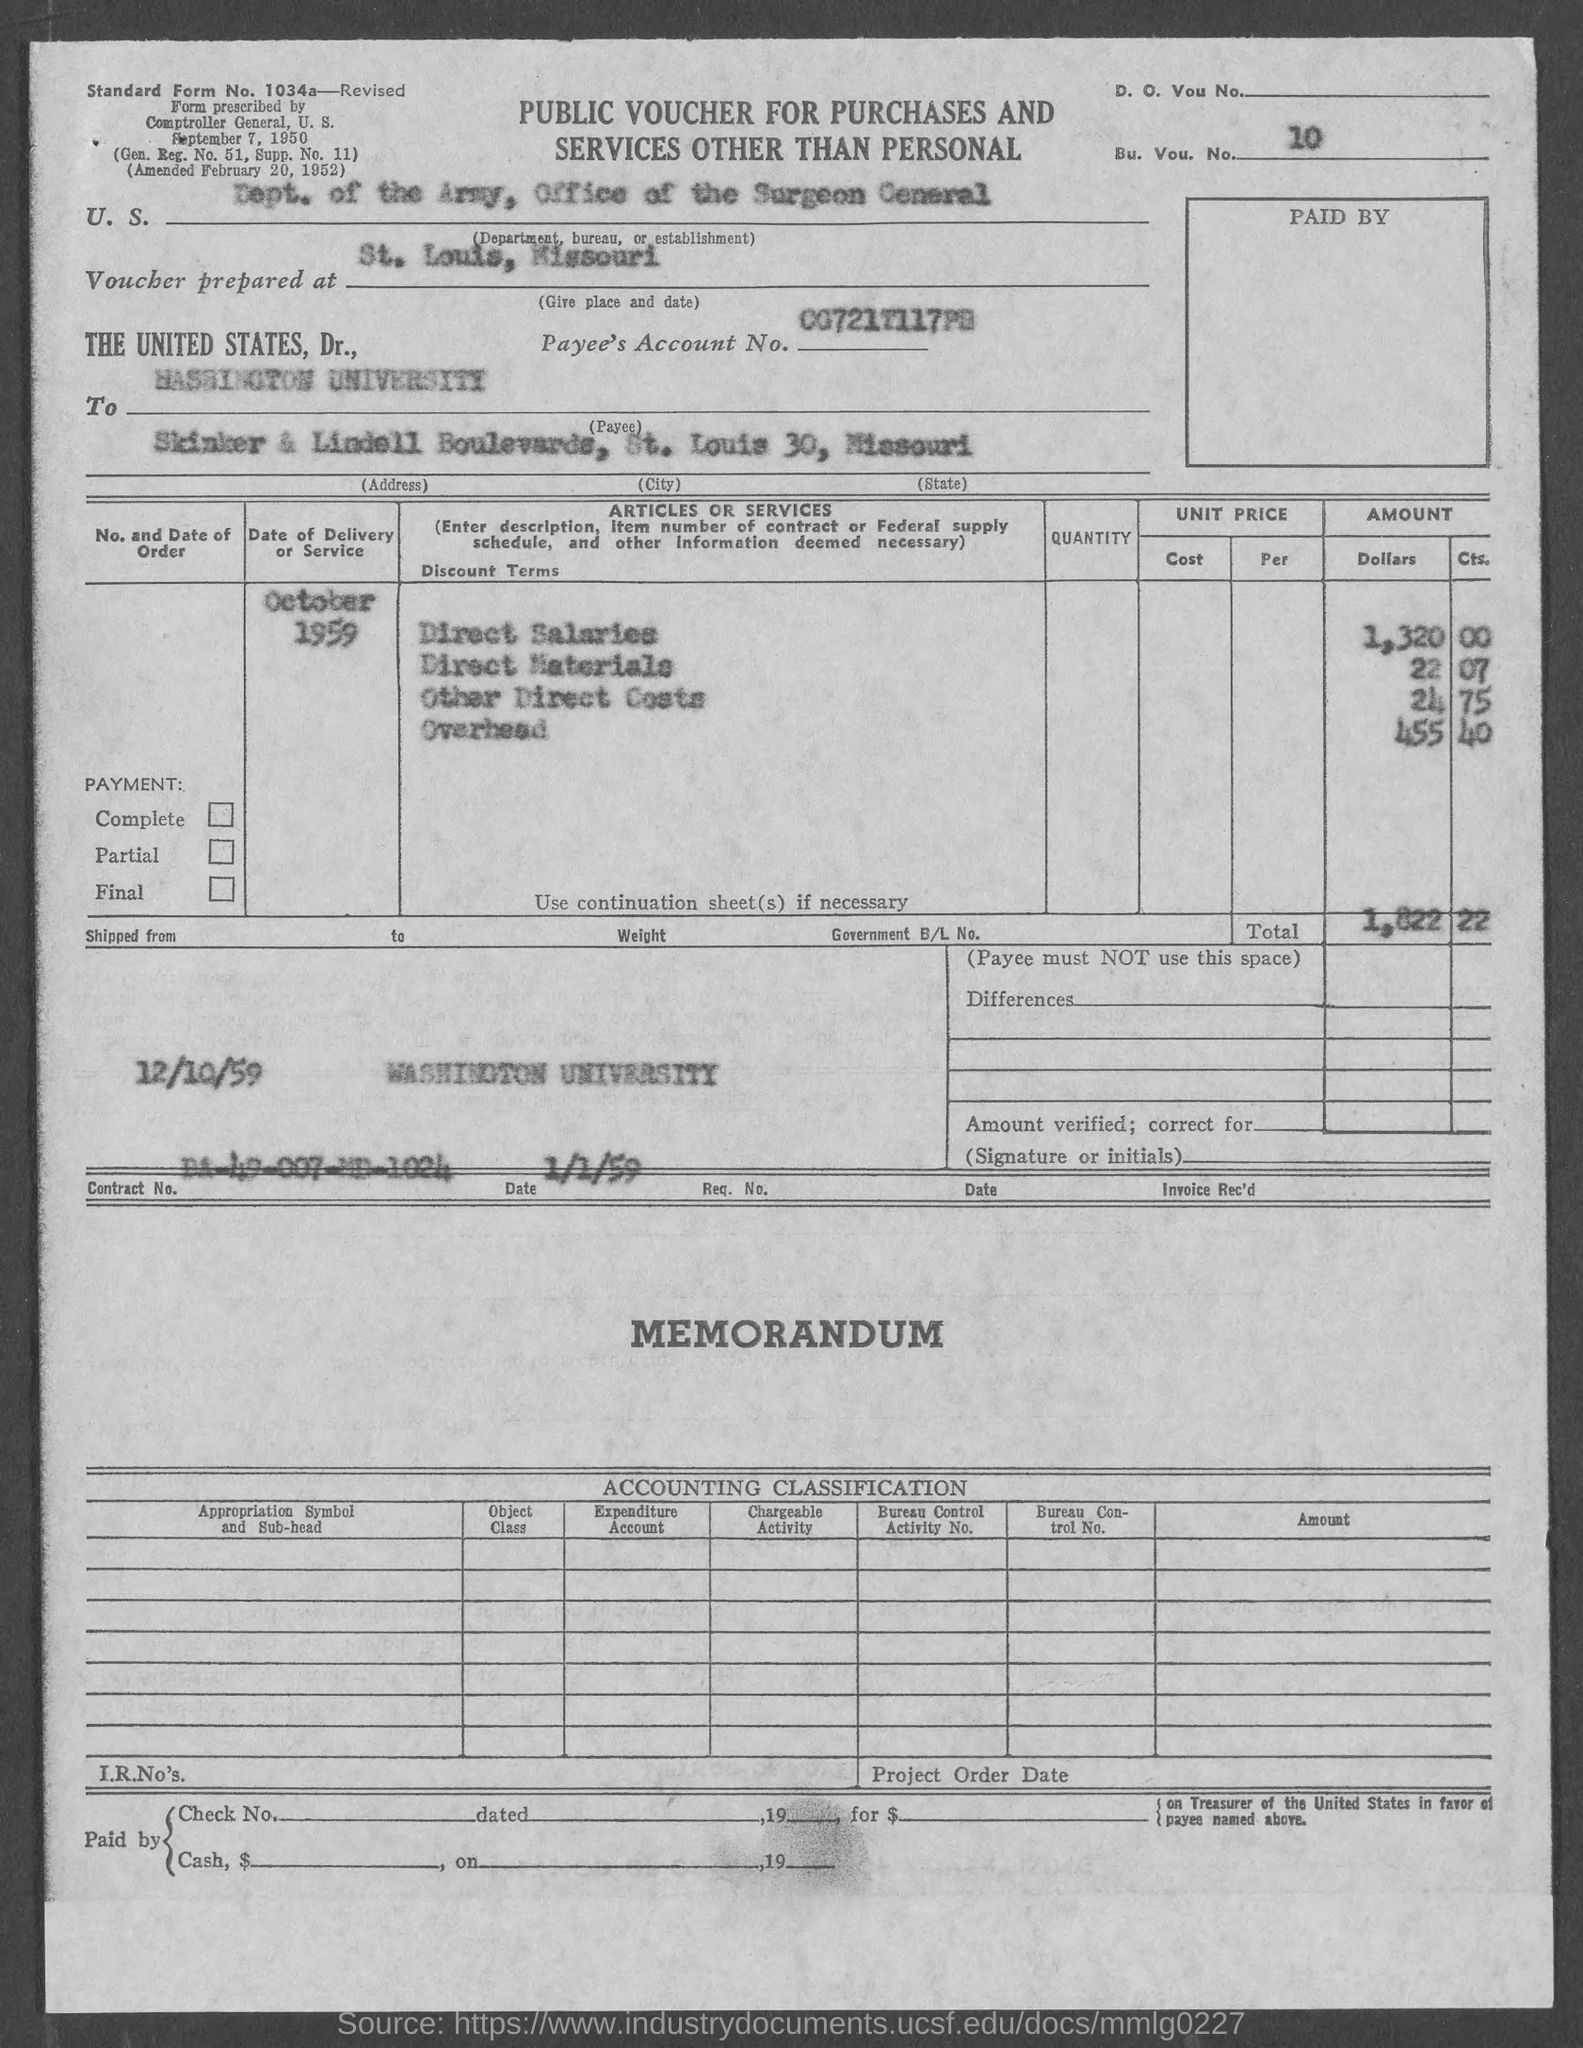The voucher is prepared for?
Your answer should be very brief. St. Louis, Missouri. What is the Bu. Vou. No.?
Provide a succinct answer. 10. What is the Payee City?
Offer a terse response. St. Louis 30. What is the Payee State?
Your answer should be very brief. Missouri. Who is the Payee?
Provide a succinct answer. WASHINGTON UNIVERSITY. What is the amount for Direct salaries?
Keep it short and to the point. 1,320 00. What is the amount for Direct Materials?
Make the answer very short. 22.07. What is the amount for other Direct costs?
Keep it short and to the point. 24 75. What is the amount for Overhead?
Your response must be concise. 455 40. 